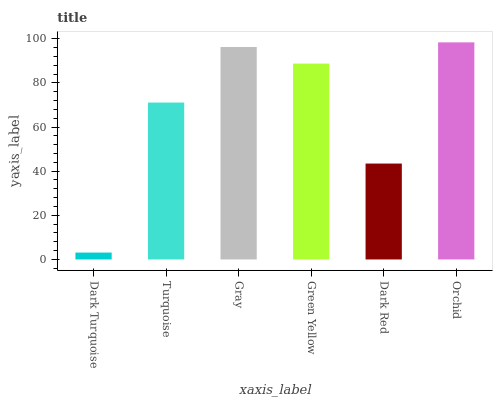Is Dark Turquoise the minimum?
Answer yes or no. Yes. Is Orchid the maximum?
Answer yes or no. Yes. Is Turquoise the minimum?
Answer yes or no. No. Is Turquoise the maximum?
Answer yes or no. No. Is Turquoise greater than Dark Turquoise?
Answer yes or no. Yes. Is Dark Turquoise less than Turquoise?
Answer yes or no. Yes. Is Dark Turquoise greater than Turquoise?
Answer yes or no. No. Is Turquoise less than Dark Turquoise?
Answer yes or no. No. Is Green Yellow the high median?
Answer yes or no. Yes. Is Turquoise the low median?
Answer yes or no. Yes. Is Gray the high median?
Answer yes or no. No. Is Orchid the low median?
Answer yes or no. No. 